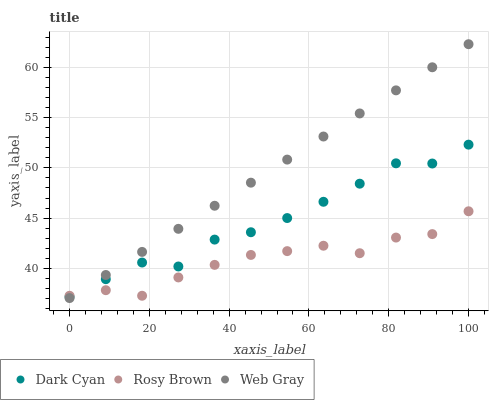Does Rosy Brown have the minimum area under the curve?
Answer yes or no. Yes. Does Web Gray have the maximum area under the curve?
Answer yes or no. Yes. Does Web Gray have the minimum area under the curve?
Answer yes or no. No. Does Rosy Brown have the maximum area under the curve?
Answer yes or no. No. Is Web Gray the smoothest?
Answer yes or no. Yes. Is Dark Cyan the roughest?
Answer yes or no. Yes. Is Rosy Brown the smoothest?
Answer yes or no. No. Is Rosy Brown the roughest?
Answer yes or no. No. Does Web Gray have the lowest value?
Answer yes or no. Yes. Does Rosy Brown have the lowest value?
Answer yes or no. No. Does Web Gray have the highest value?
Answer yes or no. Yes. Does Rosy Brown have the highest value?
Answer yes or no. No. Does Dark Cyan intersect Web Gray?
Answer yes or no. Yes. Is Dark Cyan less than Web Gray?
Answer yes or no. No. Is Dark Cyan greater than Web Gray?
Answer yes or no. No. 